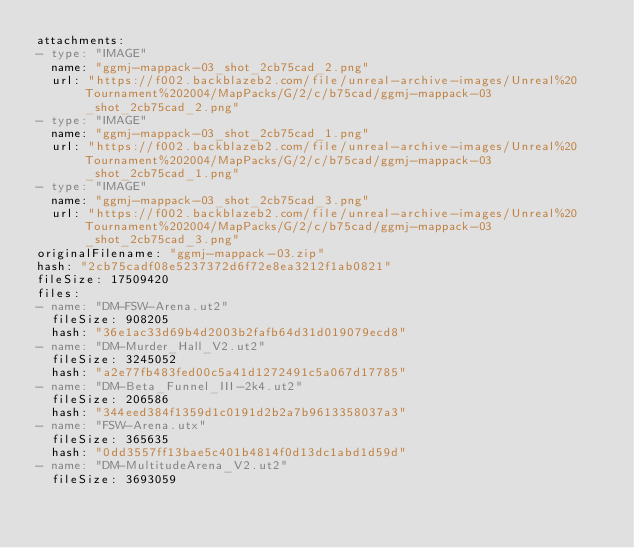Convert code to text. <code><loc_0><loc_0><loc_500><loc_500><_YAML_>attachments:
- type: "IMAGE"
  name: "ggmj-mappack-03_shot_2cb75cad_2.png"
  url: "https://f002.backblazeb2.com/file/unreal-archive-images/Unreal%20Tournament%202004/MapPacks/G/2/c/b75cad/ggmj-mappack-03_shot_2cb75cad_2.png"
- type: "IMAGE"
  name: "ggmj-mappack-03_shot_2cb75cad_1.png"
  url: "https://f002.backblazeb2.com/file/unreal-archive-images/Unreal%20Tournament%202004/MapPacks/G/2/c/b75cad/ggmj-mappack-03_shot_2cb75cad_1.png"
- type: "IMAGE"
  name: "ggmj-mappack-03_shot_2cb75cad_3.png"
  url: "https://f002.backblazeb2.com/file/unreal-archive-images/Unreal%20Tournament%202004/MapPacks/G/2/c/b75cad/ggmj-mappack-03_shot_2cb75cad_3.png"
originalFilename: "ggmj-mappack-03.zip"
hash: "2cb75cadf08e5237372d6f72e8ea3212f1ab0821"
fileSize: 17509420
files:
- name: "DM-FSW-Arena.ut2"
  fileSize: 908205
  hash: "36e1ac33d69b4d2003b2fafb64d31d019079ecd8"
- name: "DM-Murder_Hall_V2.ut2"
  fileSize: 3245052
  hash: "a2e77fb483fed00c5a41d1272491c5a067d17785"
- name: "DM-Beta_Funnel_III-2k4.ut2"
  fileSize: 206586
  hash: "344eed384f1359d1c0191d2b2a7b9613358037a3"
- name: "FSW-Arena.utx"
  fileSize: 365635
  hash: "0dd3557ff13bae5c401b4814f0d13dc1abd1d59d"
- name: "DM-MultitudeArena_V2.ut2"
  fileSize: 3693059</code> 